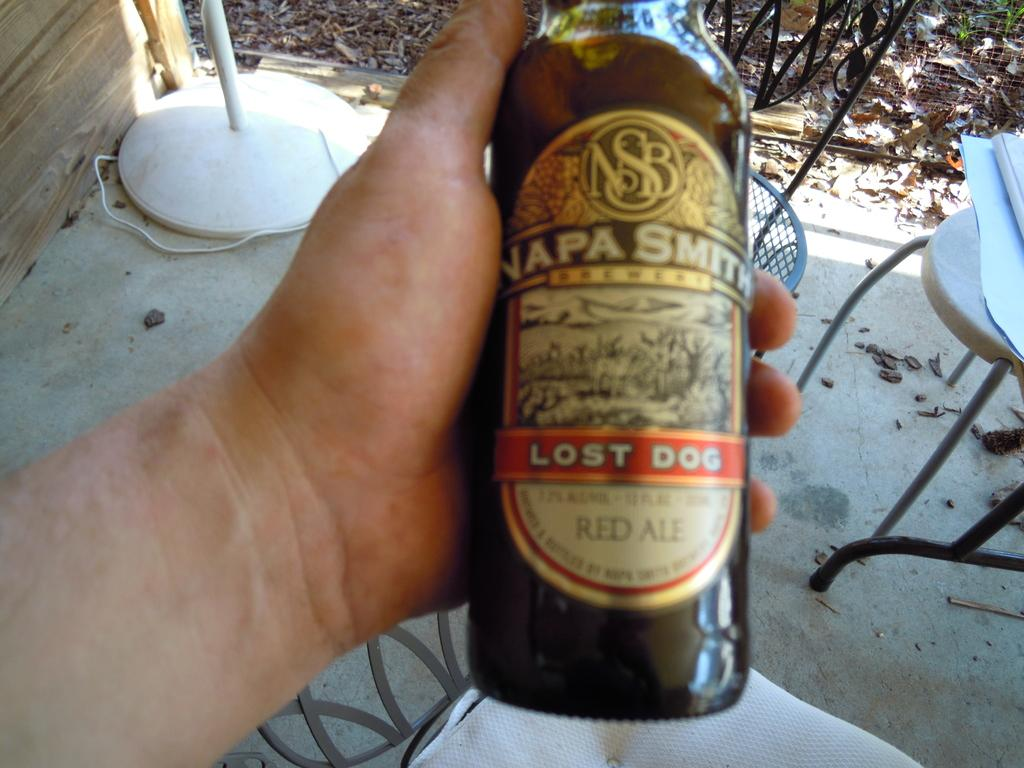<image>
Provide a brief description of the given image. A bottle of Napa Smith Lost Dog Red Ale. 